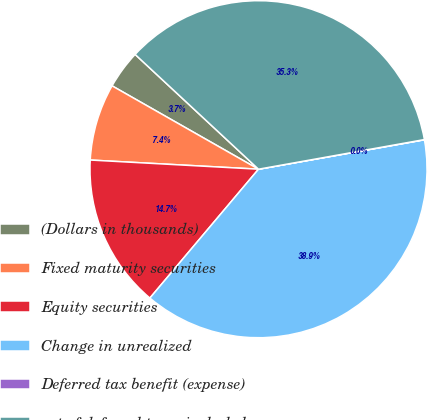Convert chart to OTSL. <chart><loc_0><loc_0><loc_500><loc_500><pie_chart><fcel>(Dollars in thousands)<fcel>Fixed maturity securities<fcel>Equity securities<fcel>Change in unrealized<fcel>Deferred tax benefit (expense)<fcel>net of deferred taxes included<nl><fcel>3.69%<fcel>7.37%<fcel>14.72%<fcel>38.94%<fcel>0.02%<fcel>35.26%<nl></chart> 